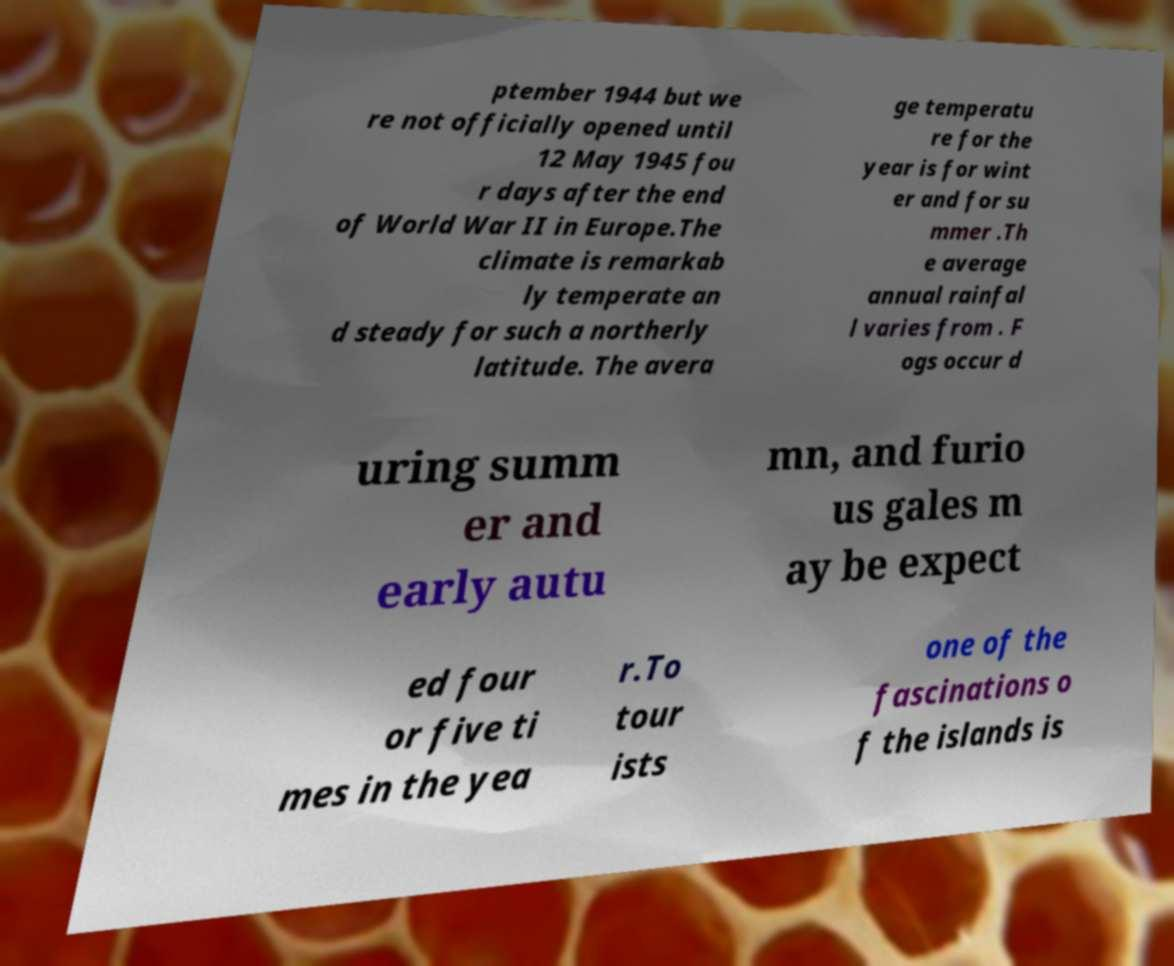I need the written content from this picture converted into text. Can you do that? ptember 1944 but we re not officially opened until 12 May 1945 fou r days after the end of World War II in Europe.The climate is remarkab ly temperate an d steady for such a northerly latitude. The avera ge temperatu re for the year is for wint er and for su mmer .Th e average annual rainfal l varies from . F ogs occur d uring summ er and early autu mn, and furio us gales m ay be expect ed four or five ti mes in the yea r.To tour ists one of the fascinations o f the islands is 